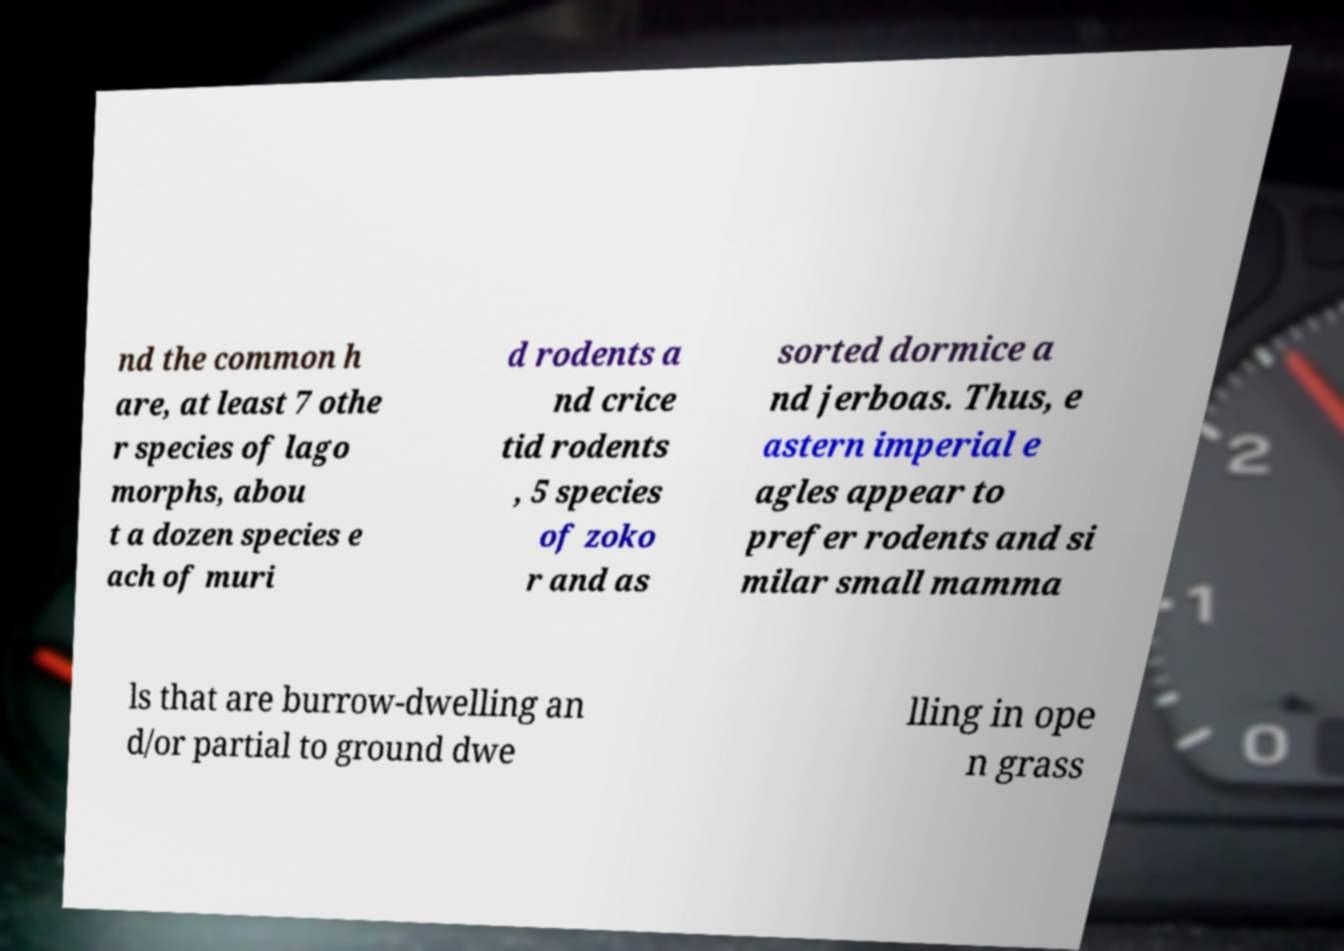Can you accurately transcribe the text from the provided image for me? nd the common h are, at least 7 othe r species of lago morphs, abou t a dozen species e ach of muri d rodents a nd crice tid rodents , 5 species of zoko r and as sorted dormice a nd jerboas. Thus, e astern imperial e agles appear to prefer rodents and si milar small mamma ls that are burrow-dwelling an d/or partial to ground dwe lling in ope n grass 